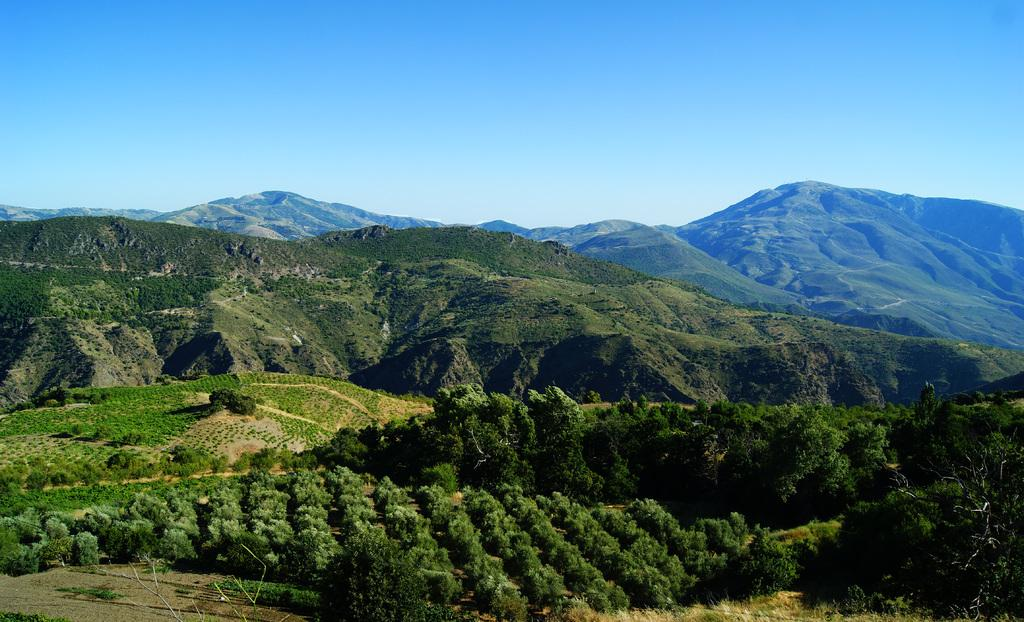What type of vegetation can be seen in the image? There is a group of plants and trees in the image. What geographical features are visible in the image? The hills are visible in the image. What part of the natural environment is visible in the image? The sky is visible in the image. How would you describe the sky in the image? The sky appears cloudy in the image. How far is the driving distance to the nearest gas station from the location depicted in the image? There is no information about a gas station or driving distance in the image, as it only features plants, trees, hills, and a cloudy sky. 